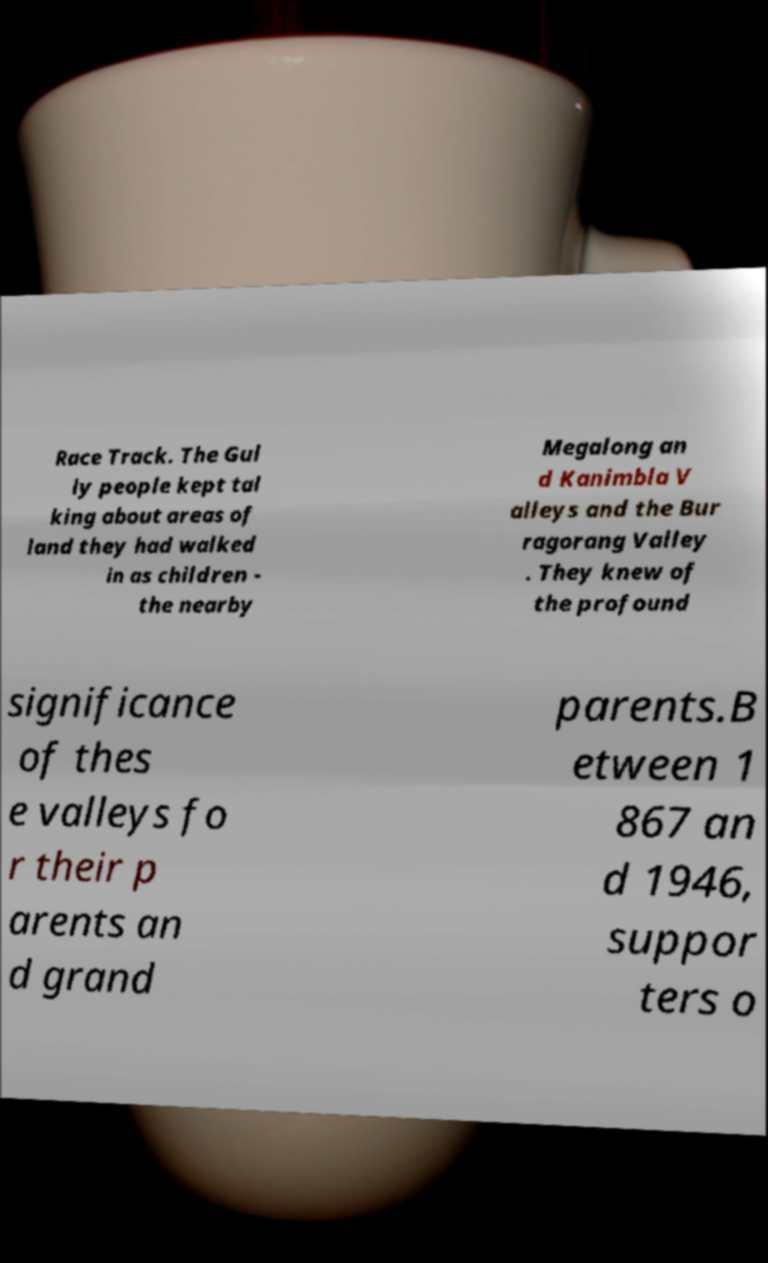Can you accurately transcribe the text from the provided image for me? Race Track. The Gul ly people kept tal king about areas of land they had walked in as children - the nearby Megalong an d Kanimbla V alleys and the Bur ragorang Valley . They knew of the profound significance of thes e valleys fo r their p arents an d grand parents.B etween 1 867 an d 1946, suppor ters o 